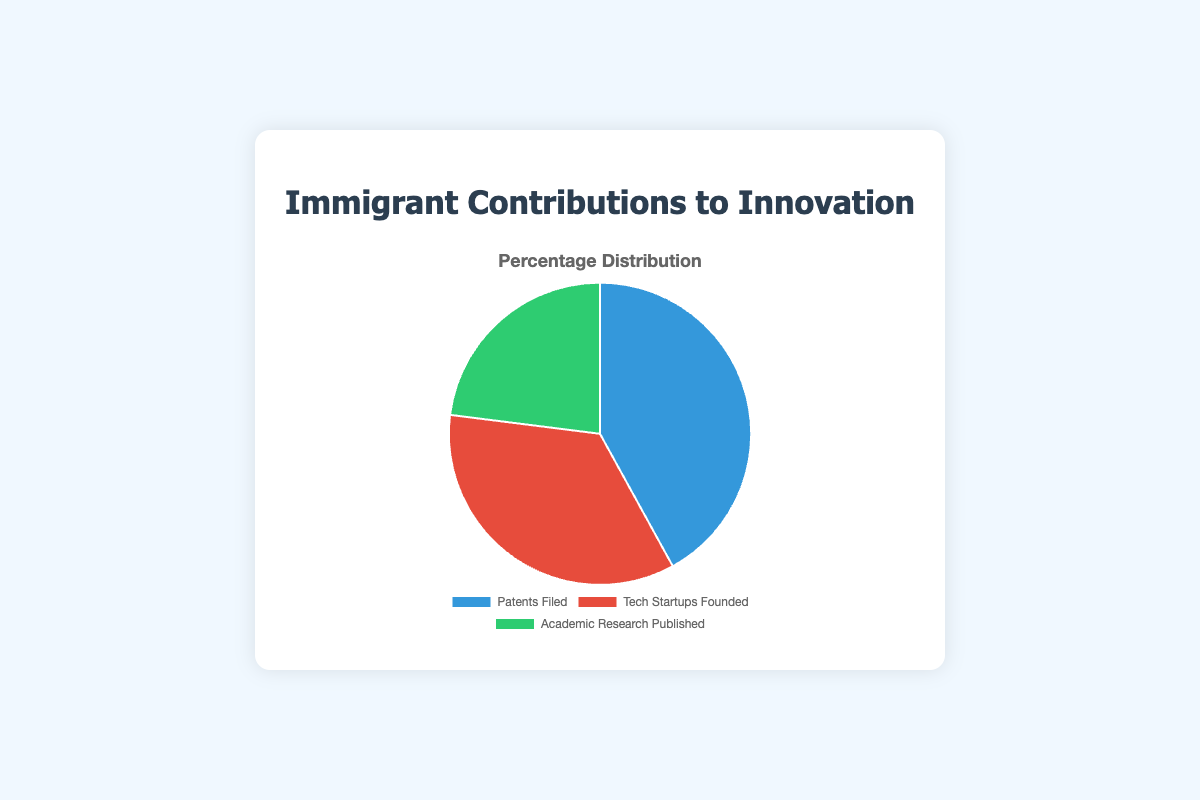Which category has the highest percentage of contributions? Look at the pie chart and identify the category with the largest slice. The 'Patents Filed' category has the largest slice, representing 42%.
Answer: Patents Filed What is the total percentage contribution of Tech Startups Founded and Academic Research Published combined? Add the percentages of Tech Startups Founded (35%) and Academic Research Published (23%). 35 + 23 = 58.
Answer: 58% By how much does the contribution of Patents Filed exceed that of Tech Startups Founded? Subtract the percentage of Tech Startups Founded (35%) from the percentage of Patents Filed (42%). 42 - 35 = 7.
Answer: 7% Which category has the smallest percentage contribution? Look at the pie chart and identify the category with the smallest slice. The 'Academic Research Published' category has the smallest slice, representing 23%.
Answer: Academic Research Published What is the difference between the highest and the lowest percentage contributions? Subtract the smallest percentage (Academic Research Published at 23%) from the largest percentage (Patents Filed at 42%). 42 - 23 = 19.
Answer: 19% What is the average percentage contribution across the three categories? Add the percentages of all three categories (42%, 35%, and 23%) and divide by the number of categories (3). (42 + 35 + 23) / 3 = 33.33.
Answer: 33.33% How much more is the contribution of Patents Filed compared to Academic Research Published? Subtract the percentage of Academic Research Published (23%) from the percentage of Patents Filed (42%). 42 - 23 = 19.
Answer: 19% If Tech Startups Founded were to increase by 5%, what would its new percentage be? Add 5% to the current percentage of Tech Startups Founded (35%). 35 + 5 = 40.
Answer: 40% What percentage of the total contributions is not from Patents Filed? Subtract the contribution of Patents Filed (42%) from 100%. 100 - 42 = 58.
Answer: 58% 